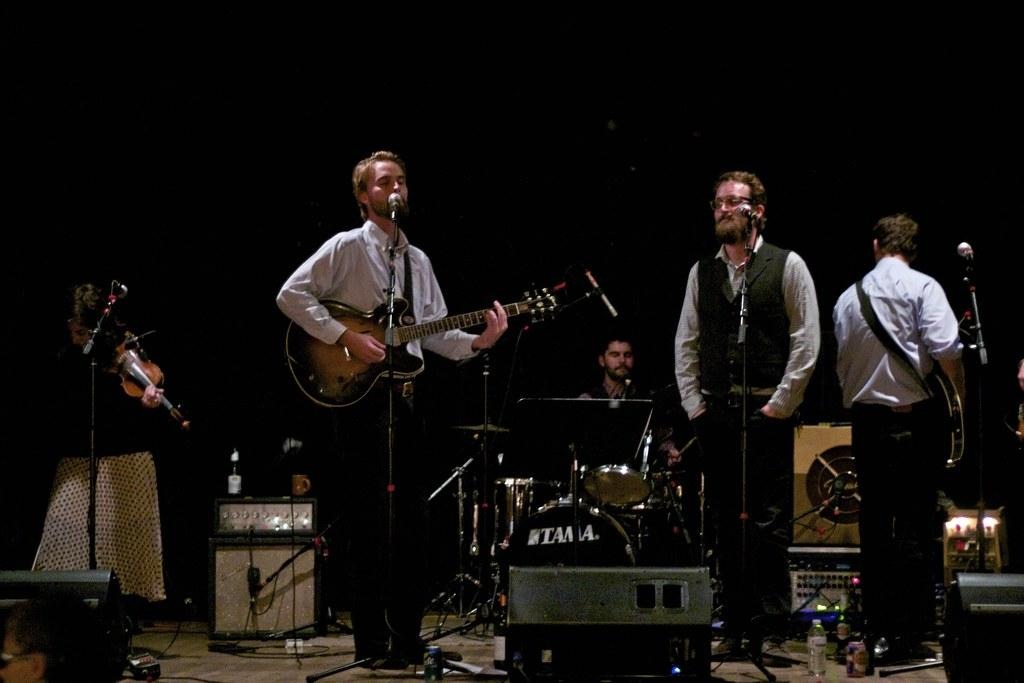What is happening on the stage in the image? There are people on the stage in the image. What are some of the people on stage doing? Some of the people on stage have musical instruments. How many people are in front of a microphone? Four people are in front of a microphone. What can be seen in the background of the image? There are equipment visible in the background of the image. Can you hear the frog singing in the image? There is no frog present in the image, so it cannot be heard singing. What type of note is being played by the quiet instrument in the image? There is no mention of a quiet instrument in the image, so it is not possible to determine the type of note being played. 